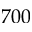Convert formula to latex. <formula><loc_0><loc_0><loc_500><loc_500>7 0 0</formula> 